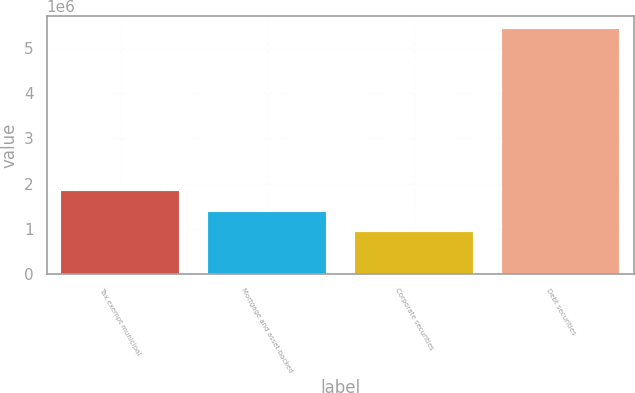Convert chart to OTSL. <chart><loc_0><loc_0><loc_500><loc_500><bar_chart><fcel>Tax exempt municipal<fcel>Mortgage and asset-backed<fcel>Corporate securities<fcel>Debt securities<nl><fcel>1.83024e+06<fcel>1.38047e+06<fcel>930707<fcel>5.42837e+06<nl></chart> 